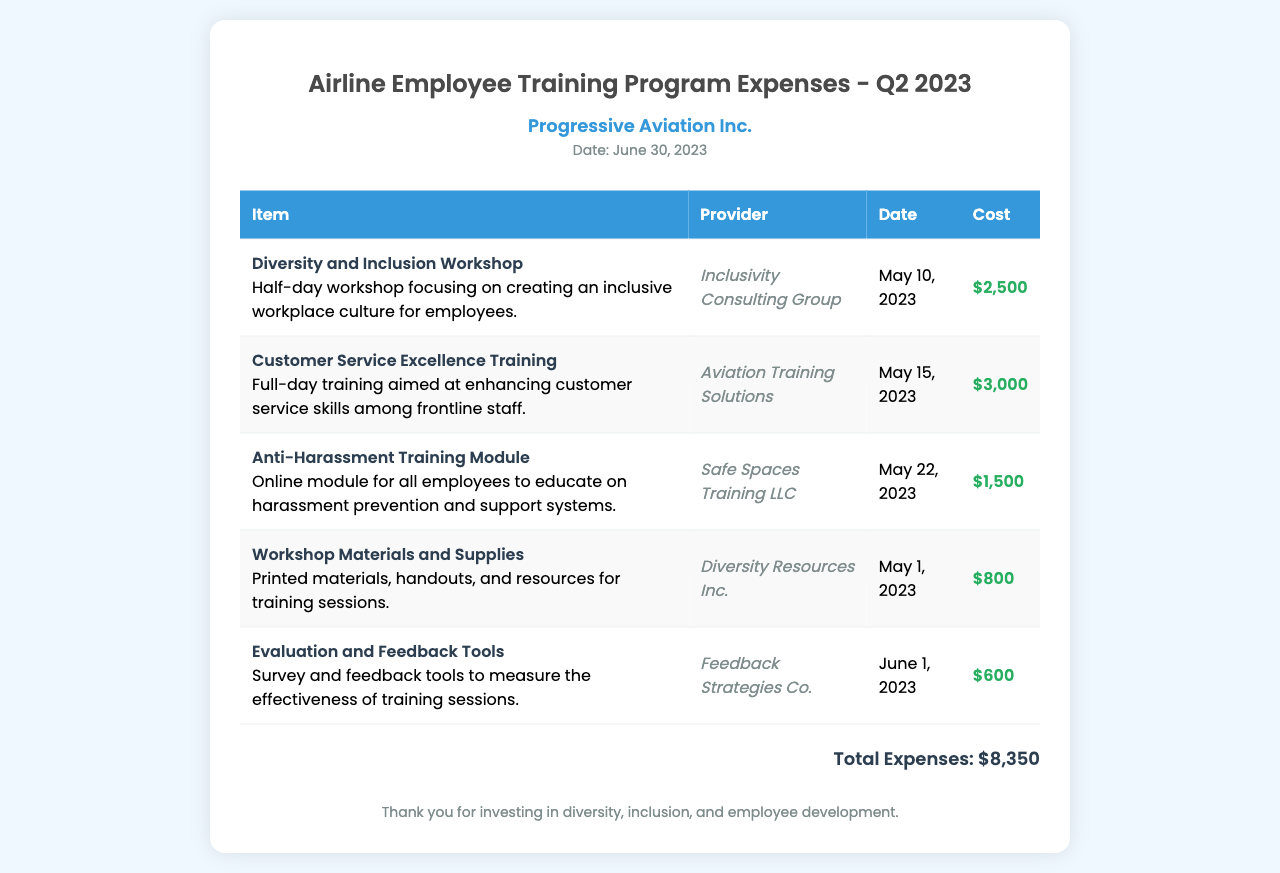What is the total amount spent on the training program in Q2 2023? The total amount spent is listed at the bottom of the document, which is the sum of all expenses.
Answer: $8,350 When was the Diversity and Inclusion Workshop conducted? The date for the workshop is specified in the document under the relevant training entry.
Answer: May 10, 2023 Who conducted the Customer Service Excellence Training? The provider of this training is mentioned in the corresponding row of the table.
Answer: Aviation Training Solutions What is the cost for the Anti-Harassment Training Module? The cost is shown in the table entry for the specific training module.
Answer: $1,500 What type of materials were purchased for the workshops? The document specifies the type of items in the entry for workshop materials and supplies.
Answer: Printed materials, handouts, and resources How many training sessions are listed in the document? To determine the number of sessions, one counts the individual entries in the table.
Answer: 5 Which provider offered the Evaluation and Feedback Tools? The provider is listed next to the relevant training item in the table.
Answer: Feedback Strategies Co What is the purpose of the Workshop Materials and Supplies entry? The entry describes what the purchased items are intended for, focusing on training sessions.
Answer: Training sessions 